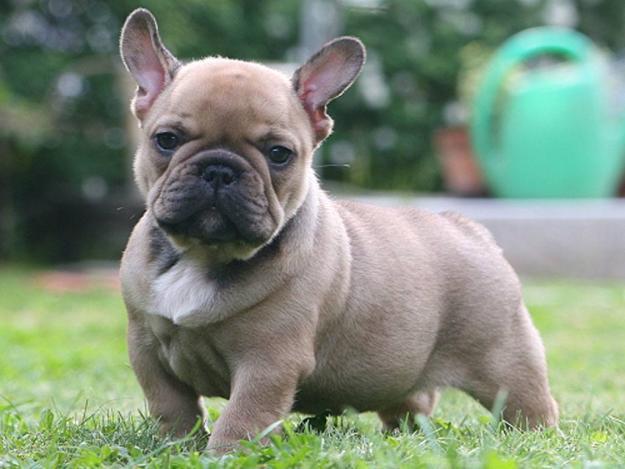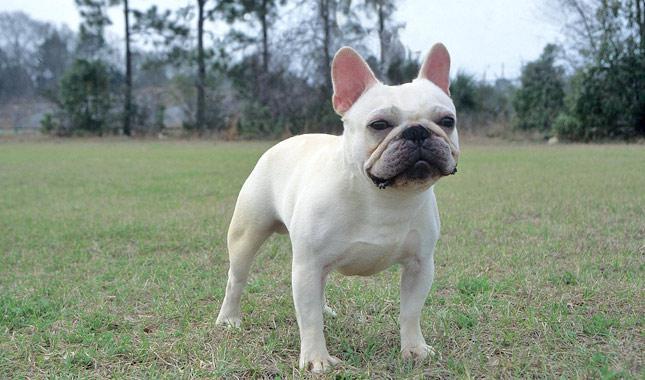The first image is the image on the left, the second image is the image on the right. For the images shown, is this caption "There are three french bulldogs" true? Answer yes or no. No. The first image is the image on the left, the second image is the image on the right. Assess this claim about the two images: "A total of two blackish dogs are shown.". Correct or not? Answer yes or no. No. 